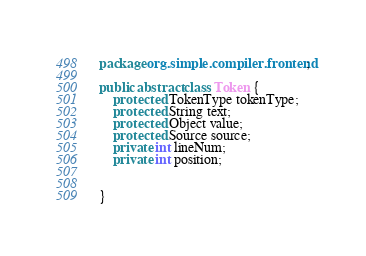<code> <loc_0><loc_0><loc_500><loc_500><_Java_>package org.simple.compiler.frontend;

public abstract class Token {
	protected TokenType tokenType;
	protected String text;
	protected Object value;
	protected Source source;
	private int lineNum;
	private int position;
	
	
}
</code> 